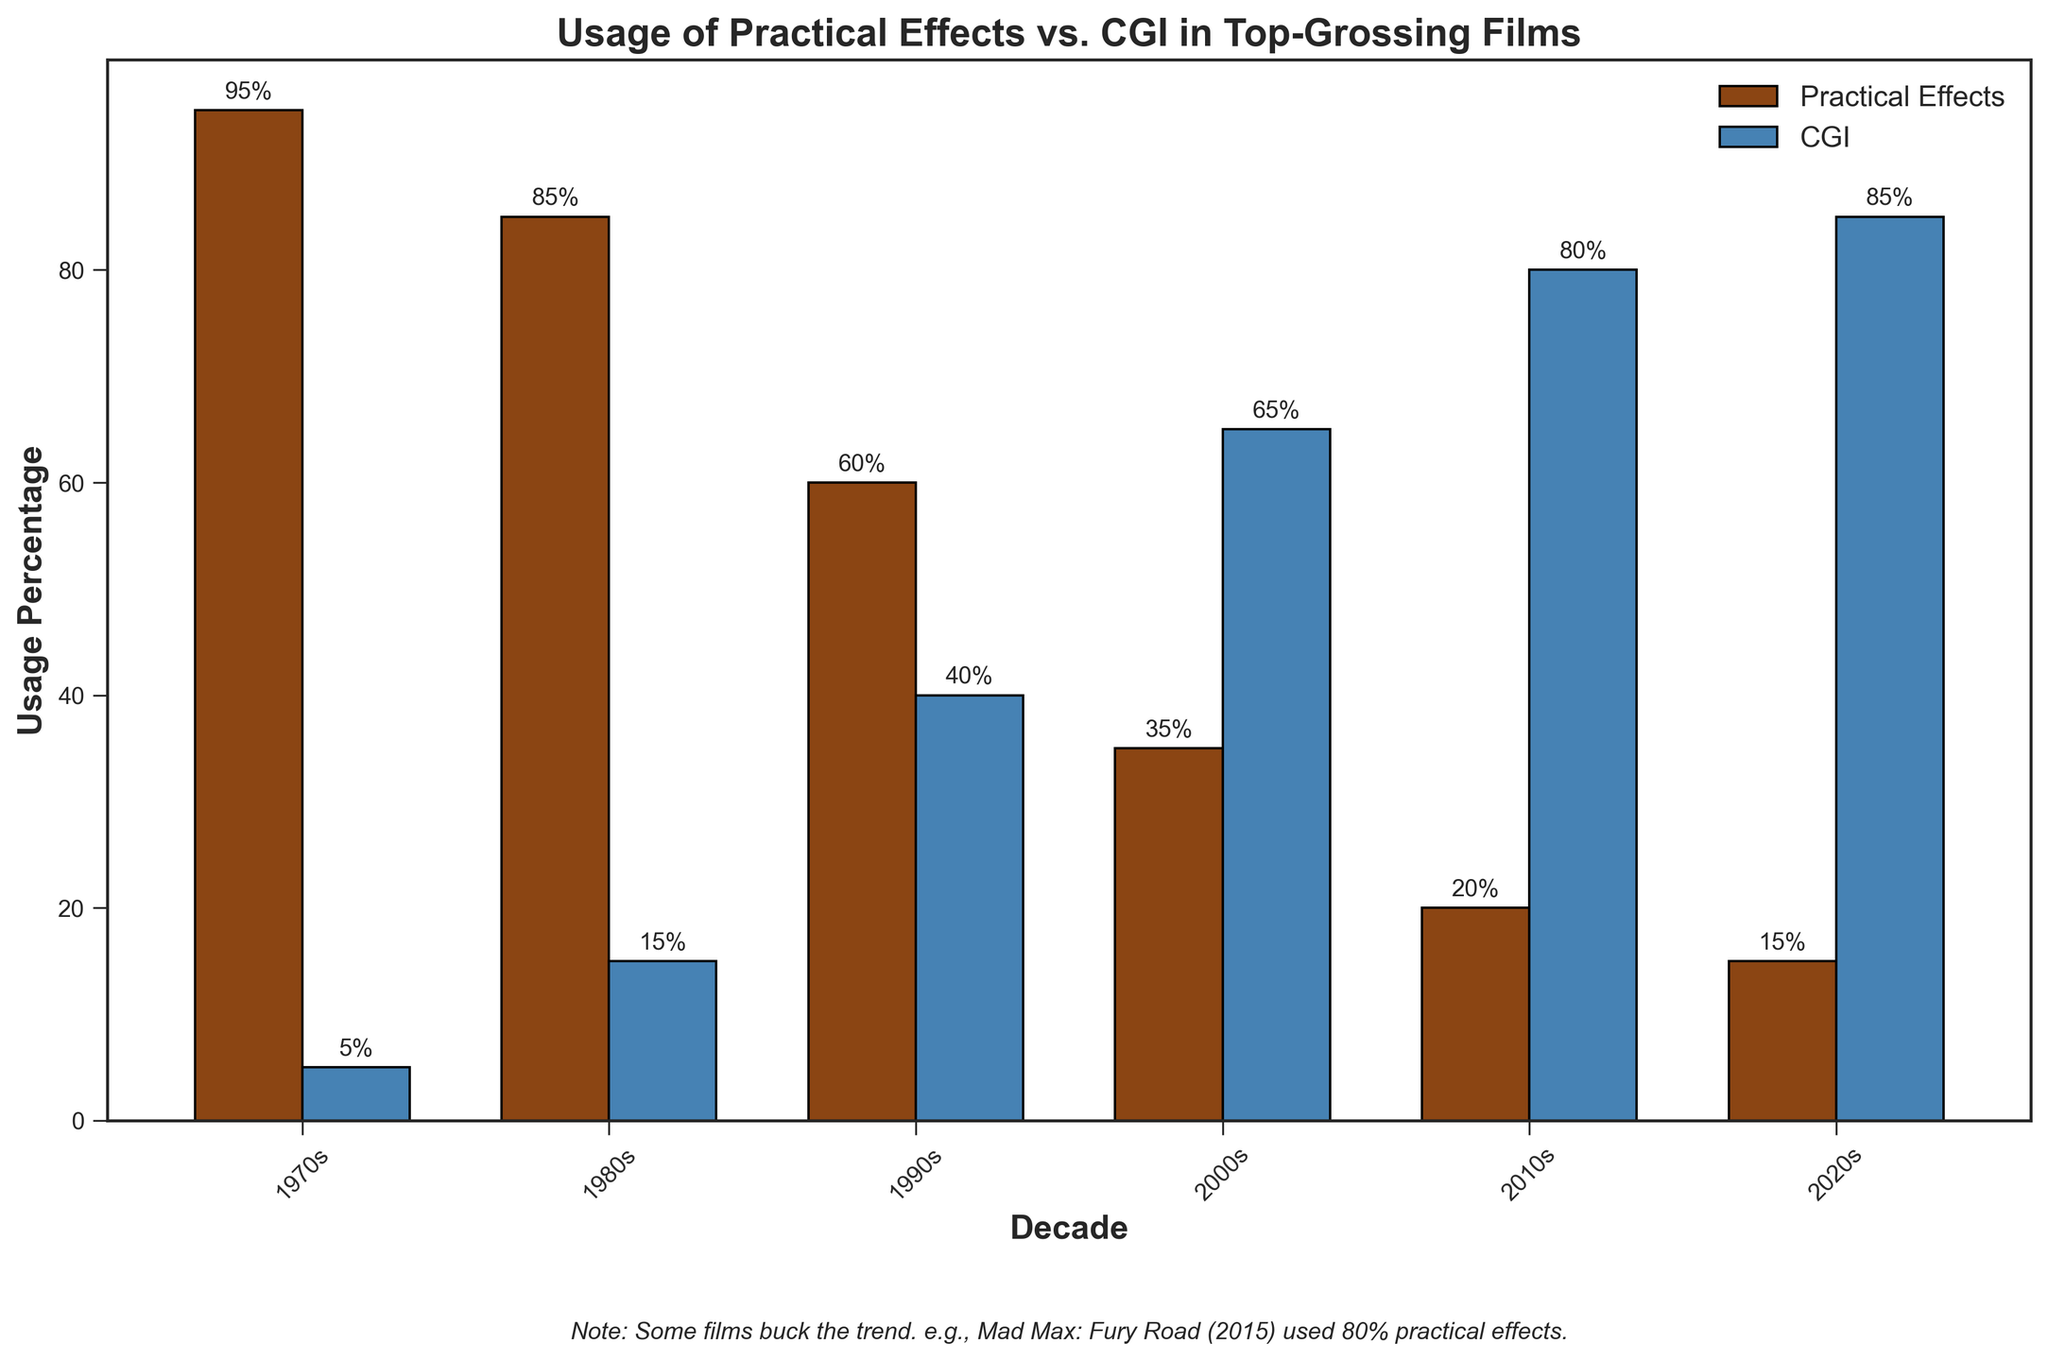What are the usage percentages of practical effects and CGI in films in the 1990s? Look at the bars corresponding to the 1990s on the figure. The practical effects bar reaches 60%, and the CGI bar reaches 40%.
Answer: Practical: 60%, CGI: 40% Which decade had the highest usage of practical effects? Compare the heights of the practical effects bars across all decades. The highest bar is in the 1970s, reaching 95%.
Answer: 1970s How did the usage of practical effects change from the 1980s to the 2000s? Look at the practical effects bars for the 1980s and the 2000s. In the 1980s, it was 85%, and in the 2000s, it was 35%. Calculate the difference: 85% - 35% = 50%.
Answer: Decreased by 50% Identify the decade with the lowest usage of practical effects. Compare the heights of the practical effects bars across all decades. The shortest bar is in the 2020s, reaching 15%.
Answer: 2020s What is the combined usage percentage of practical effects and CGI in the 2010s? Add the percentages of practical effects and CGI for the 2010s. Practical effects are 20%, and CGI is 80%. 20% + 80% = 100%.
Answer: 100% In which decade did CGI surpass practical effects in usage? Compare the heights of the practical effects and CGI bars for each decade. In the 2000s, CGI (65%) surpasses practical effects (35%) for the first time.
Answer: 2000s How does the usage of practical effects in the 2020s compare to the 1970s? Look at the heights of the practical effects bars for the 2020s and the 1970s. The 2020s has 15%, while the 1970s has 95%.
Answer: The 2020s is significantly lower What was the relationship between practical effects and CGI usage in the 2010s? Observe the heights of the bars for the 2010s. Practical effects usage is 20%, while CGI usage is 80%. Practical effects are significantly less than CGI.
Answer: CGI much higher than practical effects Calculate the average usage percentage of practical effects from 1970s to 2020s. Sum the percentages of practical effects for each decade and divide by the number of decades. (95 + 85 + 60 + 35 + 20 + 15) / 6 = 51.67%.
Answer: 51.67% What trend can be observed in the usage of CGI from 1970s to 2020s? Observe the pattern of the CGI bars over the decades. There is a clear increasing trend from 5% in the 1970s to 85% in the 2020s.
Answer: Increasing trend 